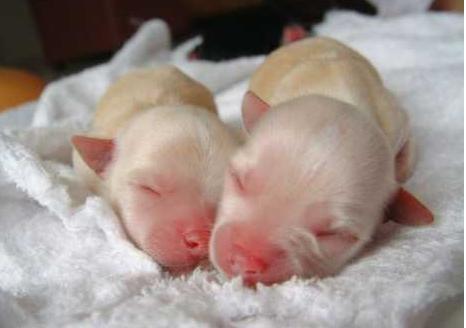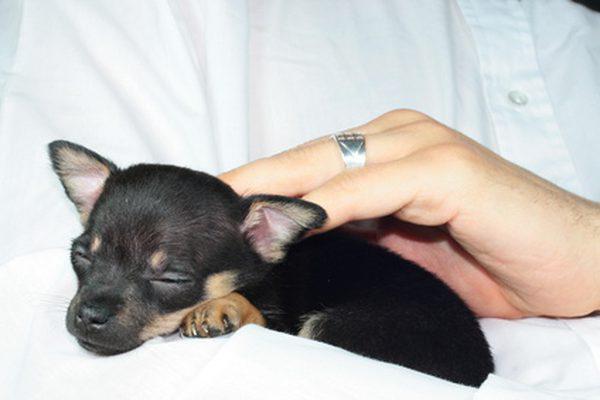The first image is the image on the left, the second image is the image on the right. Assess this claim about the two images: "There are two chihuahua puppies.". Correct or not? Answer yes or no. No. The first image is the image on the left, the second image is the image on the right. Considering the images on both sides, is "At least one animal is drinking milk." valid? Answer yes or no. No. 